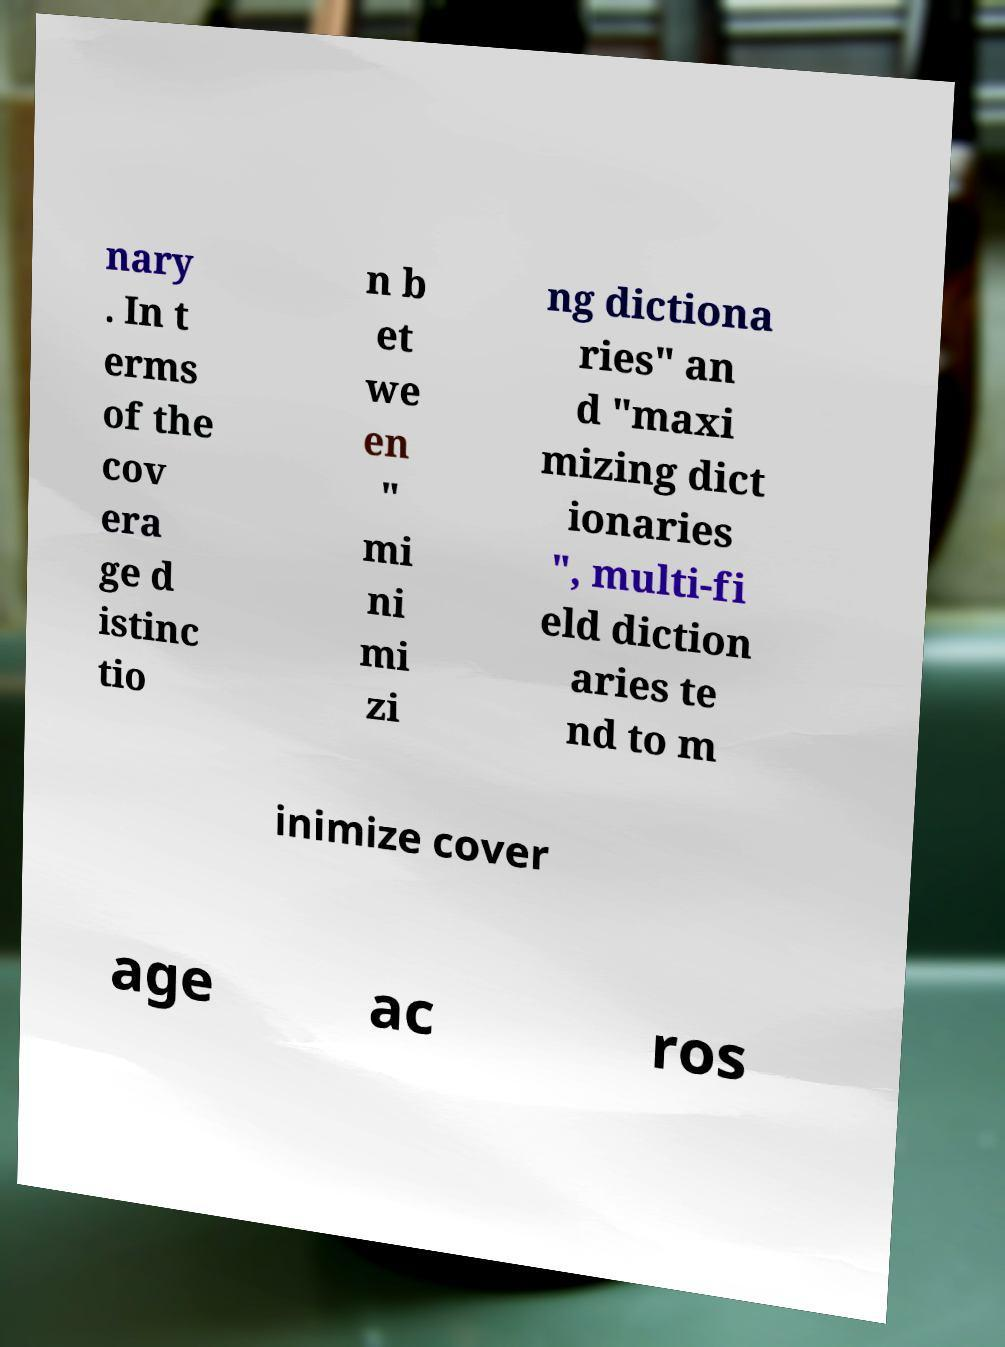Please identify and transcribe the text found in this image. nary . In t erms of the cov era ge d istinc tio n b et we en " mi ni mi zi ng dictiona ries" an d "maxi mizing dict ionaries ", multi-fi eld diction aries te nd to m inimize cover age ac ros 